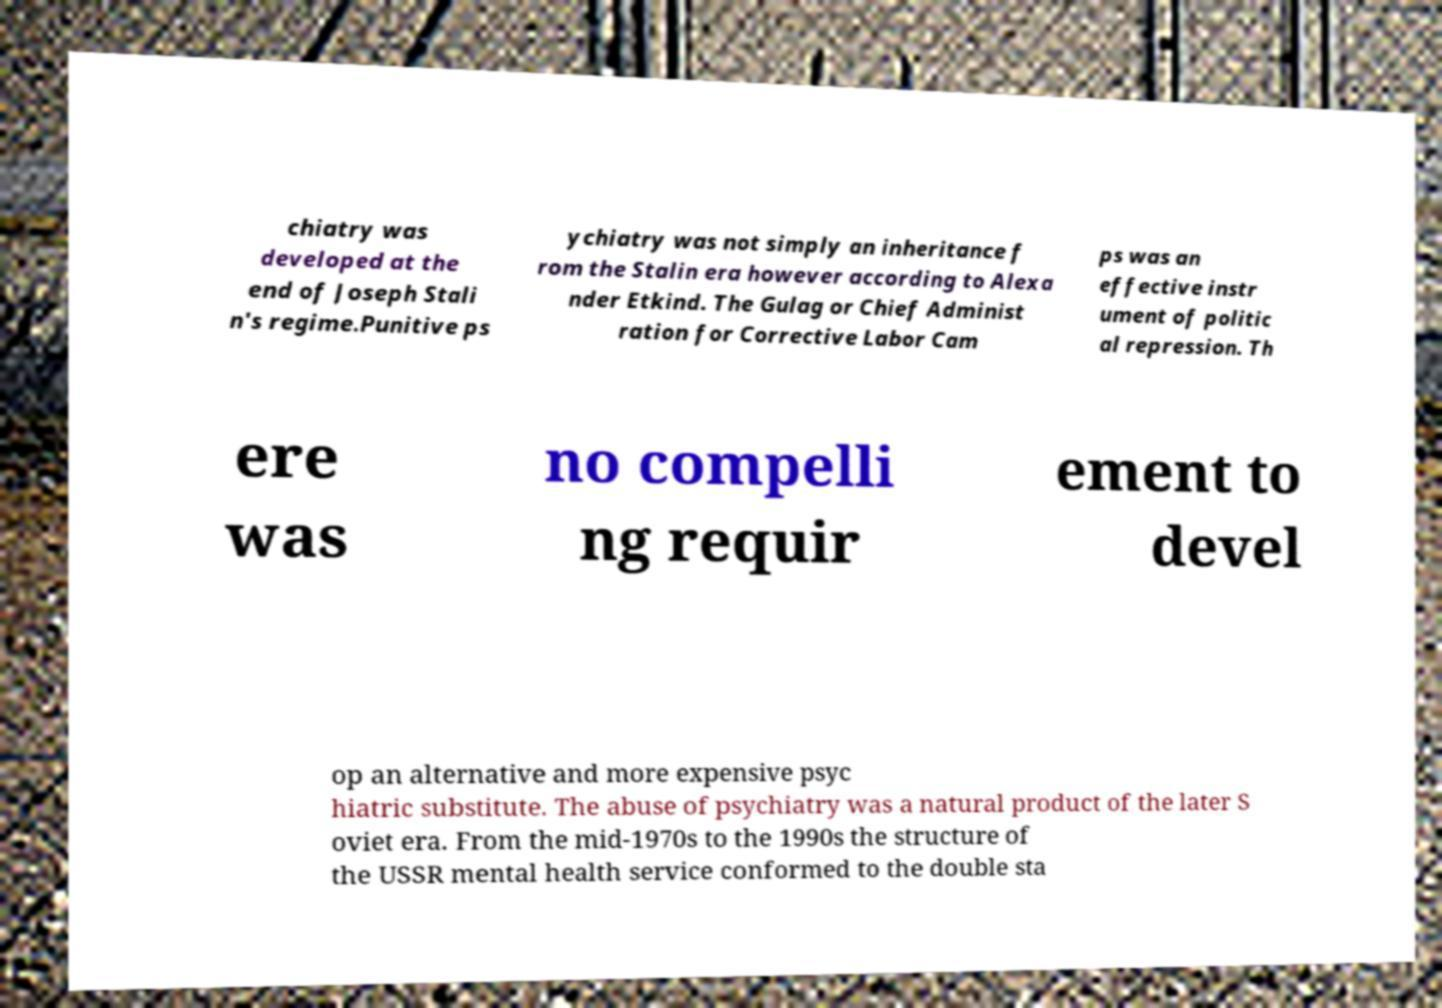For documentation purposes, I need the text within this image transcribed. Could you provide that? chiatry was developed at the end of Joseph Stali n's regime.Punitive ps ychiatry was not simply an inheritance f rom the Stalin era however according to Alexa nder Etkind. The Gulag or Chief Administ ration for Corrective Labor Cam ps was an effective instr ument of politic al repression. Th ere was no compelli ng requir ement to devel op an alternative and more expensive psyc hiatric substitute. The abuse of psychiatry was a natural product of the later S oviet era. From the mid-1970s to the 1990s the structure of the USSR mental health service conformed to the double sta 